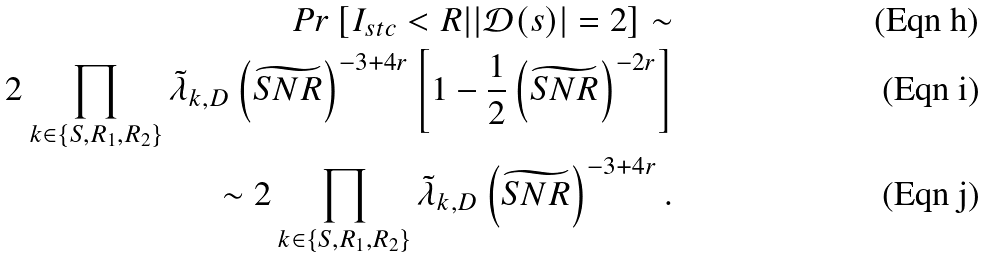<formula> <loc_0><loc_0><loc_500><loc_500>P r \left [ I _ { s t c } < R | | { \mathcal { D } } ( s ) | = 2 \right ] \sim \\ 2 \prod _ { k \in \left \{ S , R _ { 1 } , R _ { 2 } \right \} } \tilde { \lambda } _ { k , D } \left ( \widetilde { S N R } \right ) ^ { - 3 + 4 r } \left [ 1 - \frac { 1 } { 2 } \left ( \widetilde { S N R } \right ) ^ { - 2 r } \right ] \\ \sim 2 \prod _ { k \in \left \{ S , R _ { 1 } , R _ { 2 } \right \} } \tilde { \lambda } _ { k , D } \left ( \widetilde { S N R } \right ) ^ { - 3 + 4 r } .</formula> 